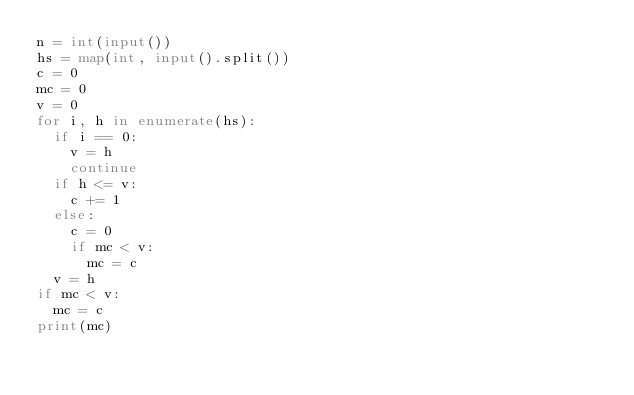<code> <loc_0><loc_0><loc_500><loc_500><_Python_>n = int(input())
hs = map(int, input().split())
c = 0
mc = 0
v = 0
for i, h in enumerate(hs):
  if i == 0:
    v = h
    continue
  if h <= v:
    c += 1
  else:
    c = 0
    if mc < v:
      mc = c
  v = h
if mc < v:
  mc = c
print(mc)</code> 